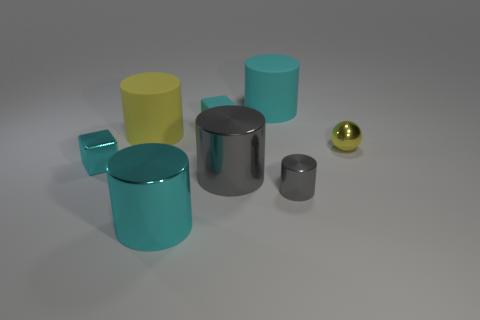Subtract 2 cylinders. How many cylinders are left? 3 Subtract all big yellow cylinders. How many cylinders are left? 4 Add 1 gray shiny things. How many objects exist? 9 Subtract 0 red blocks. How many objects are left? 8 Subtract all blocks. How many objects are left? 6 Subtract all yellow blocks. Subtract all cyan cylinders. How many blocks are left? 2 Subtract all cyan blocks. How many brown balls are left? 0 Subtract all blue things. Subtract all cyan blocks. How many objects are left? 6 Add 6 big matte objects. How many big matte objects are left? 8 Add 6 tiny yellow metallic balls. How many tiny yellow metallic balls exist? 7 